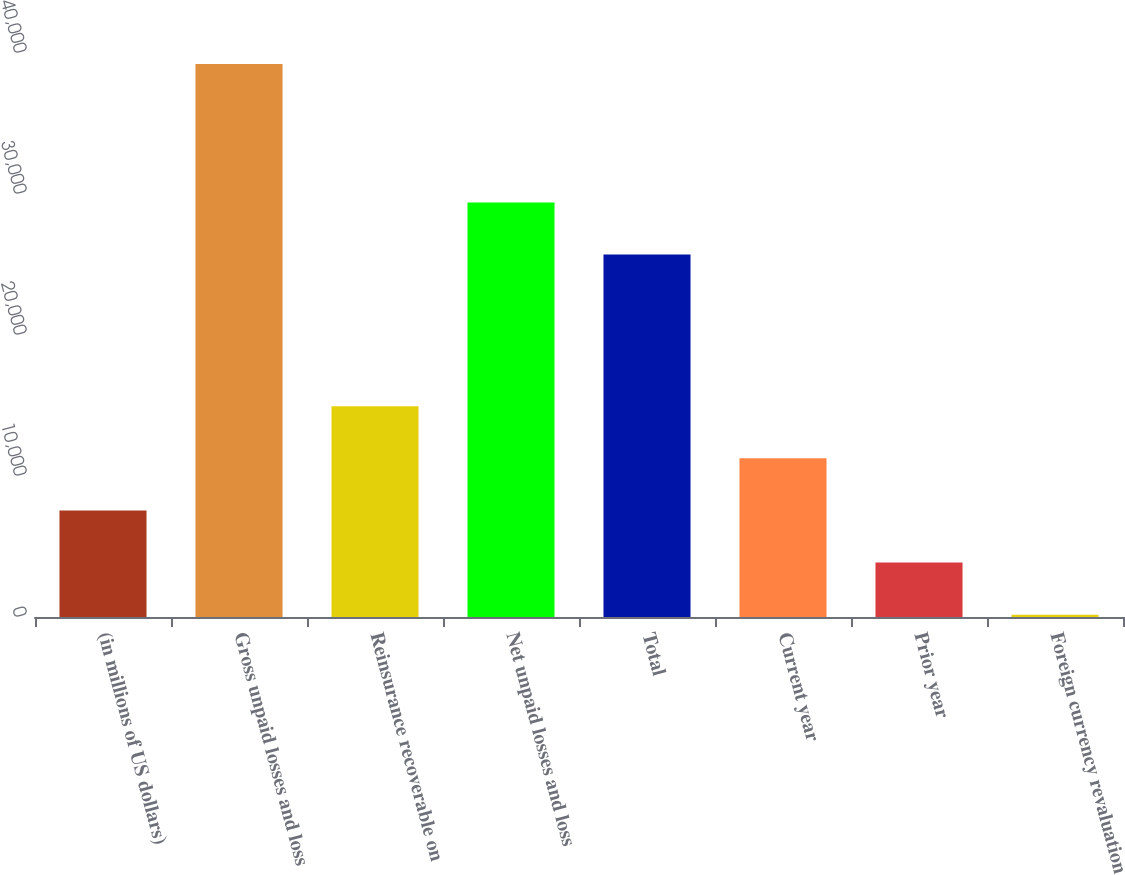<chart> <loc_0><loc_0><loc_500><loc_500><bar_chart><fcel>(in millions of US dollars)<fcel>Gross unpaid losses and loss<fcel>Reinsurance recoverable on<fcel>Net unpaid losses and loss<fcel>Total<fcel>Current year<fcel>Prior year<fcel>Foreign currency revaluation<nl><fcel>7556<fcel>39211.5<fcel>14945<fcel>29397<fcel>25702.5<fcel>11250.5<fcel>3861.5<fcel>167<nl></chart> 